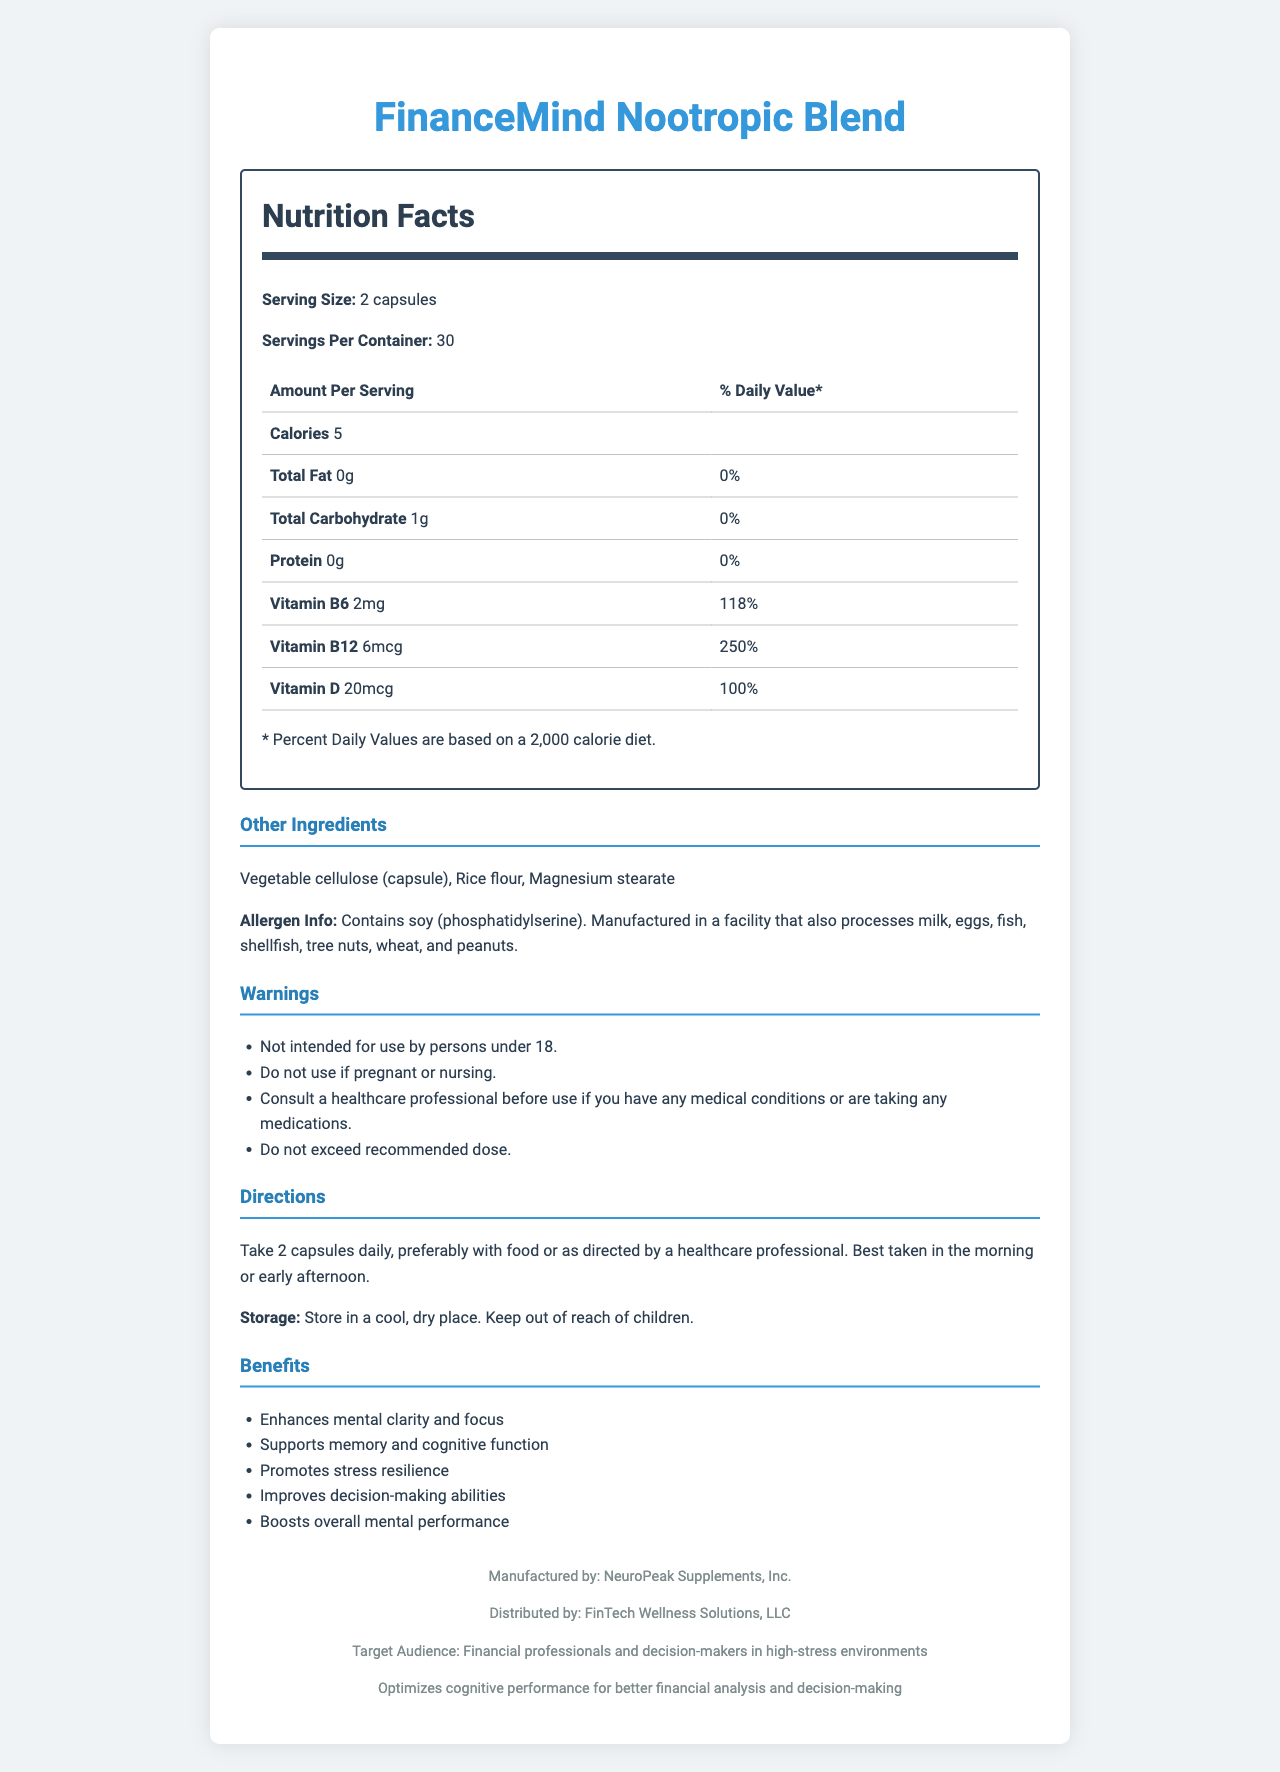what is the serving size? The document specifies that the serving size is "2 capsules" under the Nutrition Facts section at the top.
Answer: 2 capsules how many servings are in a container? The document states there are 30 servings per container, located under the Nutrition Facts section.
Answer: 30 how many calories are there per serving? The document lists that each serving contains 5 calories, found in the Nutrition Facts table.
Answer: 5 calories what is the amount of caffeine in each serving? Each serving contains 100mg of caffeine, as specified in the ingredient details in the Nutrition Facts section.
Answer: 100mg which vitamins are included in the supplement, and in what amounts? The document lists these specific vitamins and their amounts under the Nutrition Facts section.
Answer: Vitamin B6 - 2mg, Vitamin B12 - 6mcg, Vitamin D - 20mcg what is the recommended daily dose of the supplement? The recommended dosage is in the Directions section where it specifies how to take the supplement.
Answer: Take 2 capsules daily, preferably with food or as directed by a healthcare professional does this supplement contain any allergens? The Allergen Info section in the document states that it contains soy.
Answer: Yes, it contains soy (phosphatidylserine) is this product intended for use by children? One of the warnings specified is: "Not intended for use by persons under 18."
Answer: No does the supplement support stress resilience? One of the listed benefits of the product is: "Promotes stress resilience."
Answer: Yes where should the supplement be stored? The proper storage instructions are specified under the Directions section.
Answer: Store in a cool, dry place. Keep out of reach of children. what are the main benefits of the supplement? The main benefits are listed comprehensively in the Benefits section of the document, detailing the positive effects intended for users.
Answer: Enhances mental clarity and focus, supports memory and cognitive function, promotes stress resilience, improves decision-making abilities, boosts overall mental performance which company manufactures the FinanceMind Nootropic Blend? A. NeuroPeak Supplements, Inc. B. FinTech Wellness Solutions, LLC C. NutritionPlus Lab D. HealthPeak Industries The document states that the manufacturer is NeuroPeak Supplements, Inc., indicated in the footer of the document.
Answer: A what ingredients are used in the other ingredients section? A. Bacopa Monnieri, Rhodiola Rosea B. Phosphatidylserine, N-Acetyl L-Tyrosine C. Vegetable cellulose (capsule), Rice flour, Magnesium stearate D. Alpha-GPC, Ginkgo Biloba The Other Ingredients section lists "Vegetable cellulose (capsule), Rice flour, Magnesium stearate."
Answer: C are the daily recommended values given for all ingredients? The document only provides daily values for some vitamins such as Vitamin B6, B12, and D, not for all ingredients.
Answer: No please summarize the key information in this document. The document provides clear and informative details about the supplement's nutritional content, usage, and intended benefits, catering to professionals in high-stress environments.
Answer: This document provides detailed nutrition facts for the FinanceMind Nootropic Blend, including serving size, list of ingredients, and amounts per serving. It includes directions for use, a list of benefits, allergen information, and storage instructions. The supplement is specifically designed to enhance cognitive performance and is targeted at financial professionals. how does the amount of caffeine compare to the amount of L-theanine in each serving? The Nutrition Facts section lists 200mg of L-Theanine and 100mg of caffeine per serving, showing that L-Theanine is twice the amount of caffeine.
Answer: L-Theanine is double the amount of caffeine (200mg vs. 100mg) what is the role of NeuroPeak Supplements, Inc.? According to the footer in the document, NeuroPeak Supplements, Inc. is responsible for manufacturing the product.
Answer: Manufacturer is the exact composition of each vitamin B6, B12, and D provided? The document lists precise amounts for Vitamin B6 (2mg), Vitamin B12 (6mcg), and Vitamin D (20mcg).
Answer: Yes what are the potential allergens mentioned? A. Milk, Eggs, Fish, Shellfish B. Soy, Wheat, Peanuts C. Tree Nuts, Milk, Egg D. All of the above The allergen information in the document notes that the product contains soy and is manufactured in a facility that also processes milk, eggs, fish, shellfish, tree nuts, wheat, and peanuts.
Answer: D what is the full chemical composition of Alpha-GPC? The document lists Alpha-GPC as one of the ingredients but does not provide its full chemical composition.
Answer: Cannot be determined 